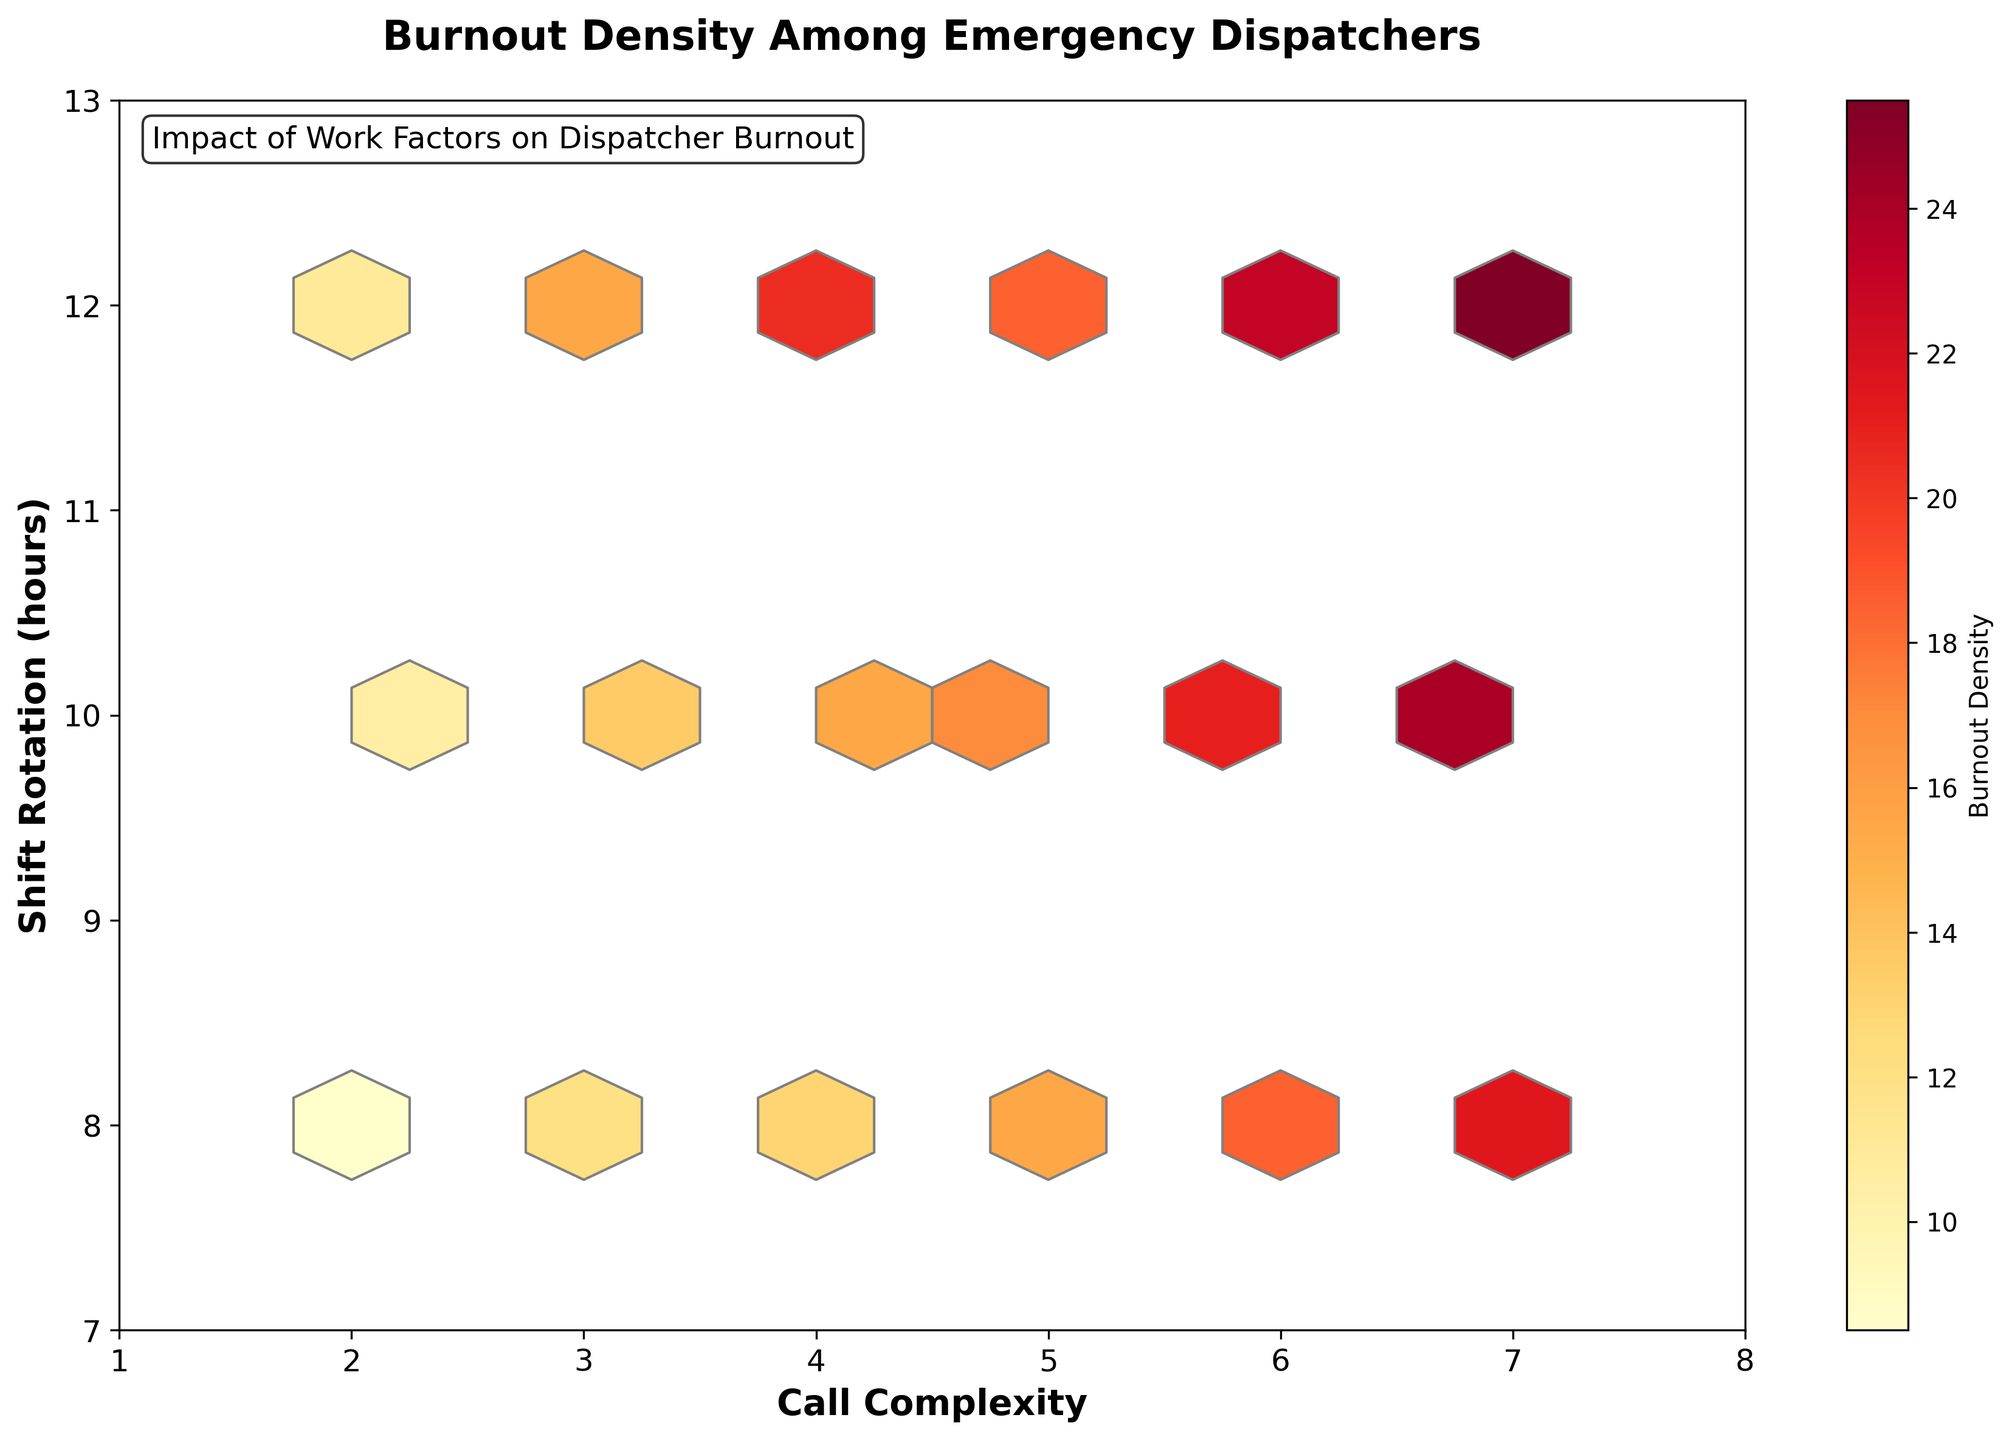What is the title of the plot? The title can be found at the top center of the plot. It clearly states what the plot represents.
Answer: Burnout Density Among Emergency Dispatchers What are the x-axis and y-axis labels? The labels for the x-axis and y-axis are usually located along the axes themselves, describing what each axis represents.
Answer: Call Complexity (x-axis) and Shift Rotation (hours) (y-axis) What does the color gradient represent in this Hexbin Plot? The color gradient typically indicates the density or intensity of the data points, often shown with a color bar.
Answer: Burnout Density What call complexity range and shift rotation range are covered in the plot? The x-axis and y-axis limits should be examined to understand the range of call complexity and shift rotation represented.
Answer: Call Complexity: 1 to 8, Shift Rotation: 7 to 13 hours What is the general trend of burnout density as call complexity increases? You need to observe how the density colors change as you move along the x-axis from left (low complexity) to right (high complexity).
Answer: It generally increases Which shift rotation hours are associated with the highest burnout density? Look at the areas with the darkest colors on the plot and note the corresponding shift rotation hours on the y-axis.
Answer: 12 hours Between call complexities 5 and 7, which level shows higher burnout density in the 10-hour shift rotation? Compare the color intensities (or bin densities) between call complexity 5 and 7, specifically at the 10-hour shift mark on the y-axis.
Answer: Call complexity 7 How does burnout density at a call complexity of 3 and an 8-hour shift compare to a call complexity of 6 and a 12-hour shift? Identify the bins corresponding to these coordinates and compare the color densities.
Answer: Call complexity 6 and 12-hour shift has higher burnout density Is there a noticeable difference in burnout density between shift rotations of 8 and 12 hours for low complexity (call complexity 2)? Observe the bins for call complexity 2 on the x-axis and compare the colors at 8 and 12 hours on the y-axis.
Answer: Yes, 12 hours shows higher burnout density What does an 8-hour shift rotation imply about burnout density across various call complexities? Review the color densities along the y-axis at the 8-hour mark and note the changes across different call complexities.
Answer: Higher call complexities generally show higher burnout densities 